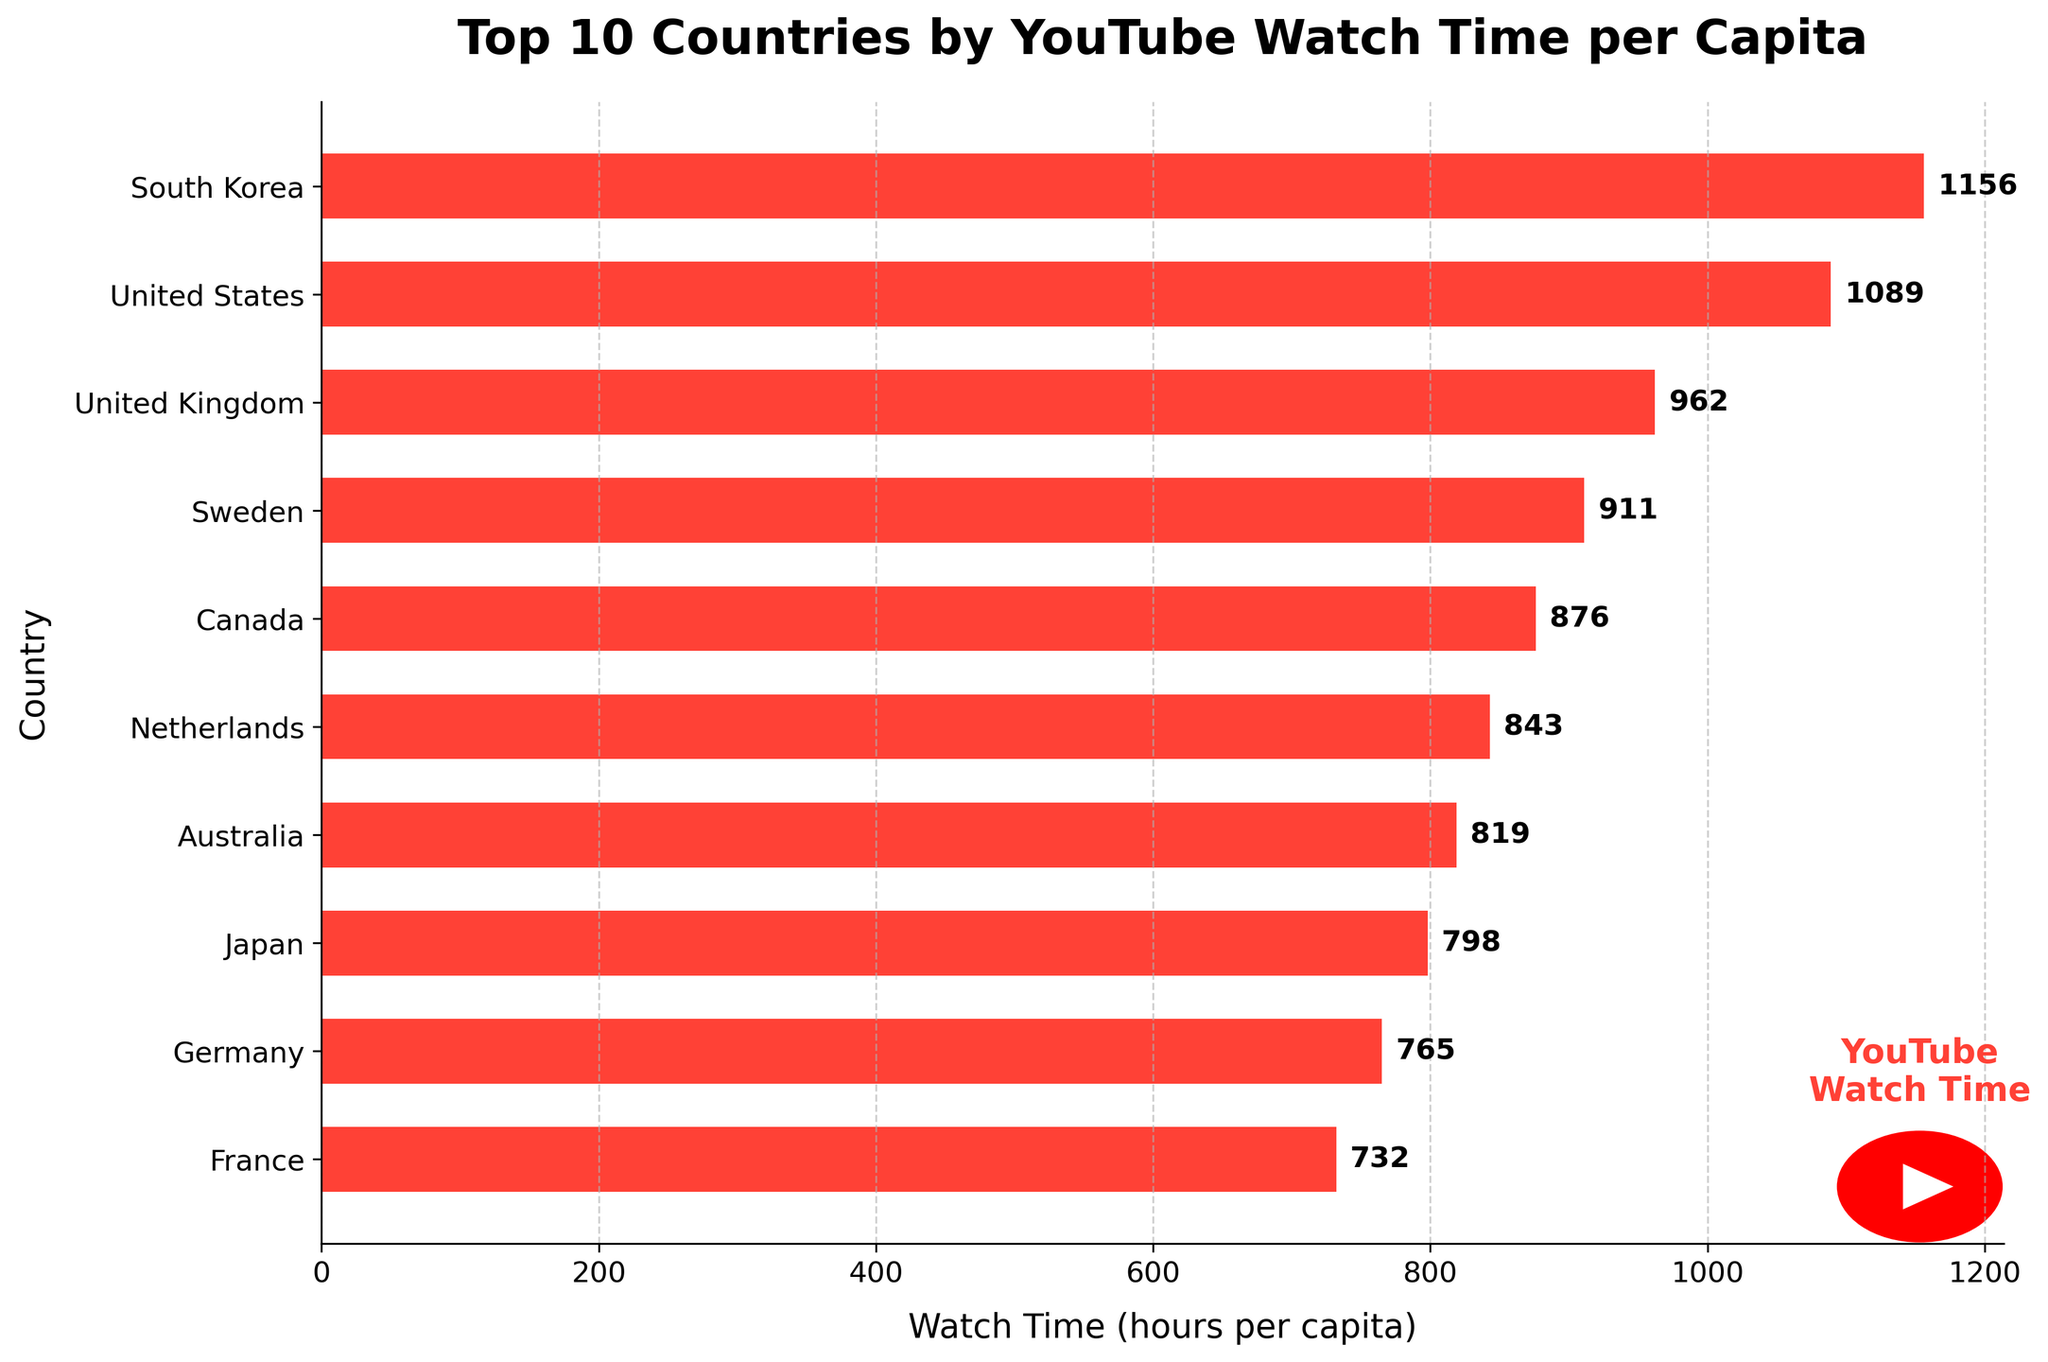Which country has the highest YouTube watch time per capita? The bar chart shows the Top 10 Countries by YouTube Watch Time per Capita, with South Korea having the longest bar, indicating the highest watch time.
Answer: South Korea Which country has the lowest YouTube watch time per capita? The bar chart shows France having the shortest bar among the listed countries, indicating the lowest watch time.
Answer: France What is the difference in watch time per capita between the top country and the second top country? South Korea has the highest watch time at 1156 hours per capita, and the United States is second with 1089 hours per capita. The difference is calculated as 1156 - 1089.
Answer: 67 How many countries have a watch time per capita greater than 900 hours? From the bar chart, South Korea, United States, United Kingdom, and Sweden have watch times over 900 hours per capita.
Answer: 4 What is the average watch time per capita for the top 3 countries? The top 3 countries are South Korea (1156), United States (1089), and United Kingdom (962). The average is calculated as (1156 + 1089 + 962) / 3.
Answer: 1069 Is Japan's watch time per capita greater than Australia's? According to the bar chart, Japan has a watch time of 798 hours per capita, and Australia has 819 hours per capita. 798 is less than 819.
Answer: No Which two countries have the closest watch times per capita? By visually examining the bars, Germany (765 hours) and France (732 hours) have the closest watch times, with a small difference of 33 hours.
Answer: Germany and France What is the total watch time per capita for all the countries combined? Summing up the watch times for all 10 countries: 1156 + 1089 + 962 + 911 + 876 + 843 + 819 + 798 + 765 + 732 = 8951.
Answer: 8951 Which country ranks 5th in terms of watch time per capita? From the bar chart, Canada ranks 5th with a watch time of 876 hours per capita.
Answer: Canada How much more is the watch time per capita in Canada compared to Japan? Canada's watch time is 876 hours per capita, and Japan's is 798 hours per capita. The difference is 876 - 798.
Answer: 78 